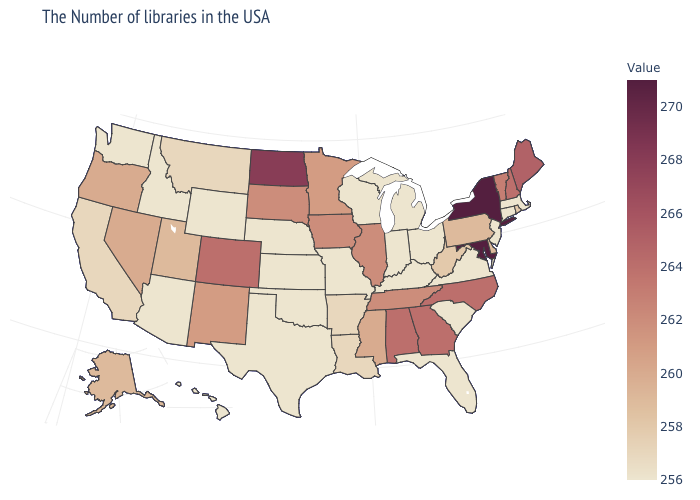Which states have the highest value in the USA?
Quick response, please. New York, Maryland. Which states have the highest value in the USA?
Quick response, please. New York, Maryland. Which states hav the highest value in the South?
Give a very brief answer. Maryland. Does New Mexico have the highest value in the USA?
Write a very short answer. No. 